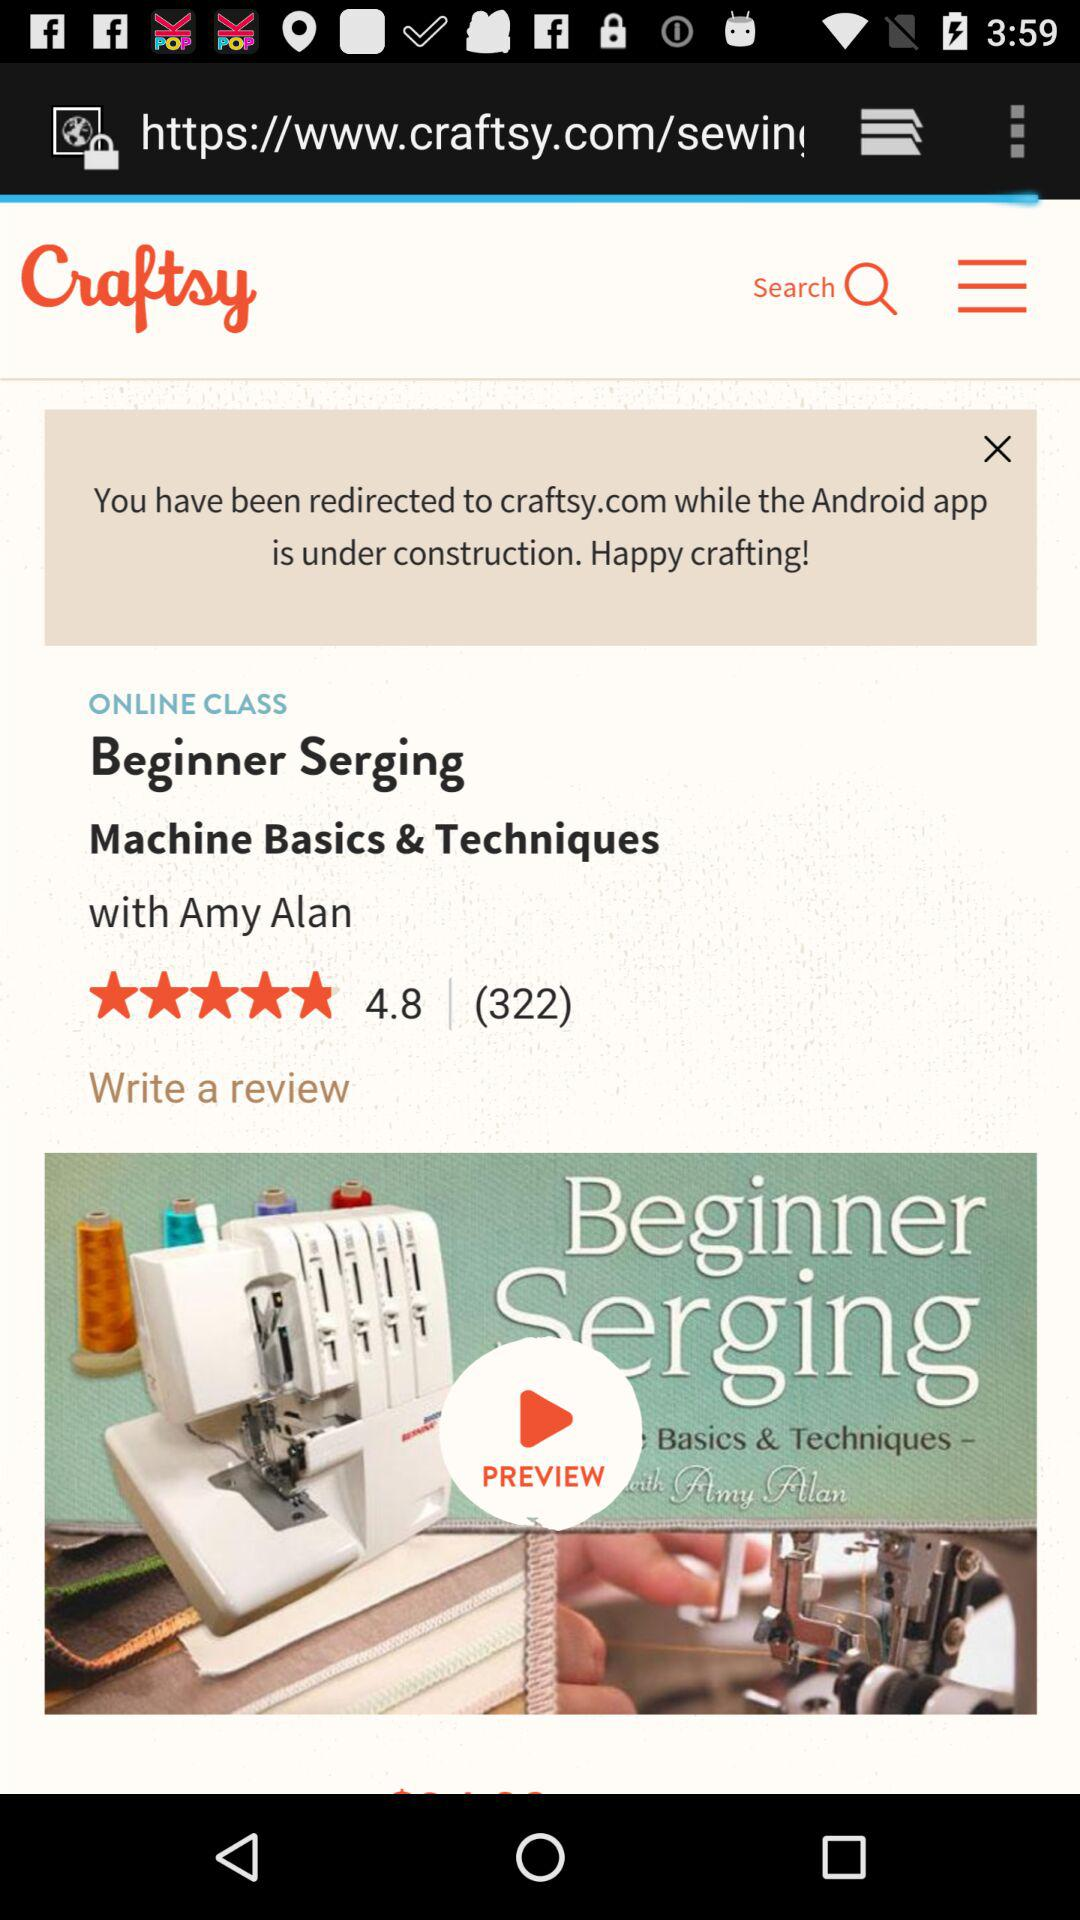What is the rating of "Beginner Serging Machine Basics & Techniques"? The rating is 4.8 stars. 